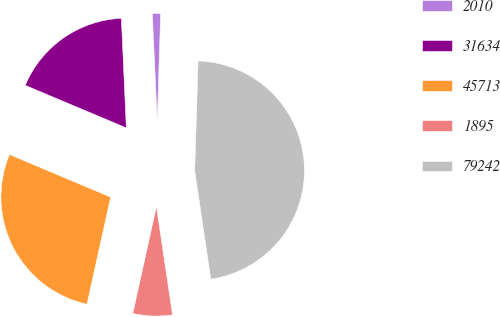Convert chart to OTSL. <chart><loc_0><loc_0><loc_500><loc_500><pie_chart><fcel>2010<fcel>31634<fcel>45713<fcel>1895<fcel>79242<nl><fcel>1.21%<fcel>17.94%<fcel>27.88%<fcel>5.8%<fcel>47.17%<nl></chart> 